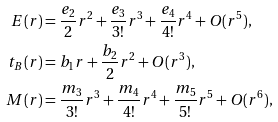<formula> <loc_0><loc_0><loc_500><loc_500>E ( r ) & = \frac { e _ { 2 } } { 2 } r ^ { 2 } + \frac { e _ { 3 } } { 3 ! } r ^ { 3 } + \frac { e _ { 4 } } { 4 ! } r ^ { 4 } + O ( r ^ { 5 } ) , \\ t _ { B } ( r ) & = { b _ { 1 } } r + \frac { b _ { 2 } } { 2 } r ^ { 2 } + O ( r ^ { 3 } ) , \\ M ( r ) & = \frac { m _ { 3 } } { 3 ! } r ^ { 3 } + \frac { m _ { 4 } } { 4 ! } r ^ { 4 } + \frac { m _ { 5 } } { 5 ! } r ^ { 5 } + O ( r ^ { 6 } ) ,</formula> 